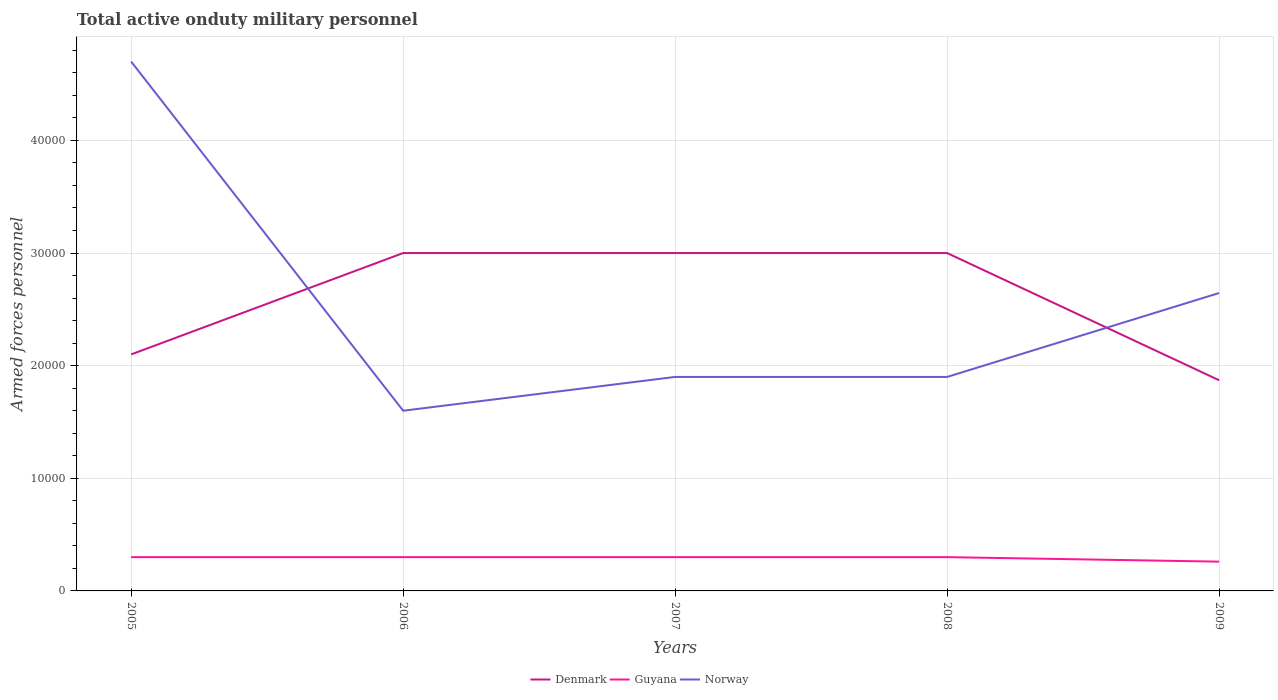Does the line corresponding to Denmark intersect with the line corresponding to Guyana?
Your response must be concise. No. Is the number of lines equal to the number of legend labels?
Keep it short and to the point. Yes. Across all years, what is the maximum number of armed forces personnel in Denmark?
Give a very brief answer. 1.87e+04. In which year was the number of armed forces personnel in Denmark maximum?
Your answer should be very brief. 2009. What is the total number of armed forces personnel in Guyana in the graph?
Your response must be concise. 400. What is the difference between the highest and the second highest number of armed forces personnel in Guyana?
Your answer should be compact. 400. What is the difference between the highest and the lowest number of armed forces personnel in Norway?
Offer a very short reply. 2. Is the number of armed forces personnel in Denmark strictly greater than the number of armed forces personnel in Guyana over the years?
Your answer should be very brief. No. How many years are there in the graph?
Your answer should be very brief. 5. What is the difference between two consecutive major ticks on the Y-axis?
Your answer should be compact. 10000. Are the values on the major ticks of Y-axis written in scientific E-notation?
Offer a terse response. No. Does the graph contain any zero values?
Ensure brevity in your answer.  No. Does the graph contain grids?
Offer a very short reply. Yes. Where does the legend appear in the graph?
Your answer should be compact. Bottom center. How are the legend labels stacked?
Your answer should be very brief. Horizontal. What is the title of the graph?
Offer a terse response. Total active onduty military personnel. What is the label or title of the X-axis?
Provide a short and direct response. Years. What is the label or title of the Y-axis?
Provide a succinct answer. Armed forces personnel. What is the Armed forces personnel in Denmark in 2005?
Give a very brief answer. 2.10e+04. What is the Armed forces personnel of Guyana in 2005?
Your response must be concise. 3000. What is the Armed forces personnel of Norway in 2005?
Your answer should be very brief. 4.70e+04. What is the Armed forces personnel of Denmark in 2006?
Provide a succinct answer. 3.00e+04. What is the Armed forces personnel of Guyana in 2006?
Your answer should be compact. 3000. What is the Armed forces personnel of Norway in 2006?
Keep it short and to the point. 1.60e+04. What is the Armed forces personnel of Denmark in 2007?
Provide a succinct answer. 3.00e+04. What is the Armed forces personnel in Guyana in 2007?
Offer a very short reply. 3000. What is the Armed forces personnel in Norway in 2007?
Provide a succinct answer. 1.90e+04. What is the Armed forces personnel in Denmark in 2008?
Provide a succinct answer. 3.00e+04. What is the Armed forces personnel of Guyana in 2008?
Your answer should be compact. 3000. What is the Armed forces personnel of Norway in 2008?
Keep it short and to the point. 1.90e+04. What is the Armed forces personnel of Denmark in 2009?
Your answer should be compact. 1.87e+04. What is the Armed forces personnel of Guyana in 2009?
Give a very brief answer. 2600. What is the Armed forces personnel of Norway in 2009?
Provide a short and direct response. 2.64e+04. Across all years, what is the maximum Armed forces personnel in Denmark?
Your answer should be very brief. 3.00e+04. Across all years, what is the maximum Armed forces personnel of Guyana?
Your answer should be compact. 3000. Across all years, what is the maximum Armed forces personnel in Norway?
Offer a very short reply. 4.70e+04. Across all years, what is the minimum Armed forces personnel of Denmark?
Your answer should be very brief. 1.87e+04. Across all years, what is the minimum Armed forces personnel of Guyana?
Provide a short and direct response. 2600. Across all years, what is the minimum Armed forces personnel of Norway?
Your answer should be compact. 1.60e+04. What is the total Armed forces personnel of Denmark in the graph?
Offer a very short reply. 1.30e+05. What is the total Armed forces personnel of Guyana in the graph?
Offer a very short reply. 1.46e+04. What is the total Armed forces personnel of Norway in the graph?
Ensure brevity in your answer.  1.27e+05. What is the difference between the Armed forces personnel in Denmark in 2005 and that in 2006?
Ensure brevity in your answer.  -9000. What is the difference between the Armed forces personnel in Norway in 2005 and that in 2006?
Your response must be concise. 3.10e+04. What is the difference between the Armed forces personnel in Denmark in 2005 and that in 2007?
Offer a very short reply. -9000. What is the difference between the Armed forces personnel of Norway in 2005 and that in 2007?
Keep it short and to the point. 2.80e+04. What is the difference between the Armed forces personnel in Denmark in 2005 and that in 2008?
Your answer should be compact. -9000. What is the difference between the Armed forces personnel of Guyana in 2005 and that in 2008?
Keep it short and to the point. 0. What is the difference between the Armed forces personnel of Norway in 2005 and that in 2008?
Your response must be concise. 2.80e+04. What is the difference between the Armed forces personnel of Denmark in 2005 and that in 2009?
Offer a terse response. 2293. What is the difference between the Armed forces personnel in Norway in 2005 and that in 2009?
Keep it short and to the point. 2.06e+04. What is the difference between the Armed forces personnel in Denmark in 2006 and that in 2007?
Your answer should be compact. 0. What is the difference between the Armed forces personnel in Norway in 2006 and that in 2007?
Give a very brief answer. -3000. What is the difference between the Armed forces personnel in Norway in 2006 and that in 2008?
Ensure brevity in your answer.  -3000. What is the difference between the Armed forces personnel of Denmark in 2006 and that in 2009?
Offer a terse response. 1.13e+04. What is the difference between the Armed forces personnel of Norway in 2006 and that in 2009?
Your answer should be compact. -1.04e+04. What is the difference between the Armed forces personnel in Denmark in 2007 and that in 2008?
Offer a very short reply. 0. What is the difference between the Armed forces personnel of Norway in 2007 and that in 2008?
Offer a very short reply. 0. What is the difference between the Armed forces personnel of Denmark in 2007 and that in 2009?
Provide a succinct answer. 1.13e+04. What is the difference between the Armed forces personnel of Norway in 2007 and that in 2009?
Your answer should be very brief. -7450. What is the difference between the Armed forces personnel of Denmark in 2008 and that in 2009?
Keep it short and to the point. 1.13e+04. What is the difference between the Armed forces personnel in Guyana in 2008 and that in 2009?
Your answer should be compact. 400. What is the difference between the Armed forces personnel in Norway in 2008 and that in 2009?
Ensure brevity in your answer.  -7450. What is the difference between the Armed forces personnel of Denmark in 2005 and the Armed forces personnel of Guyana in 2006?
Offer a very short reply. 1.80e+04. What is the difference between the Armed forces personnel in Guyana in 2005 and the Armed forces personnel in Norway in 2006?
Keep it short and to the point. -1.30e+04. What is the difference between the Armed forces personnel of Denmark in 2005 and the Armed forces personnel of Guyana in 2007?
Keep it short and to the point. 1.80e+04. What is the difference between the Armed forces personnel of Denmark in 2005 and the Armed forces personnel of Norway in 2007?
Keep it short and to the point. 2000. What is the difference between the Armed forces personnel of Guyana in 2005 and the Armed forces personnel of Norway in 2007?
Your response must be concise. -1.60e+04. What is the difference between the Armed forces personnel in Denmark in 2005 and the Armed forces personnel in Guyana in 2008?
Offer a very short reply. 1.80e+04. What is the difference between the Armed forces personnel in Denmark in 2005 and the Armed forces personnel in Norway in 2008?
Your answer should be compact. 2000. What is the difference between the Armed forces personnel of Guyana in 2005 and the Armed forces personnel of Norway in 2008?
Keep it short and to the point. -1.60e+04. What is the difference between the Armed forces personnel in Denmark in 2005 and the Armed forces personnel in Guyana in 2009?
Ensure brevity in your answer.  1.84e+04. What is the difference between the Armed forces personnel in Denmark in 2005 and the Armed forces personnel in Norway in 2009?
Your answer should be very brief. -5450. What is the difference between the Armed forces personnel in Guyana in 2005 and the Armed forces personnel in Norway in 2009?
Your response must be concise. -2.34e+04. What is the difference between the Armed forces personnel of Denmark in 2006 and the Armed forces personnel of Guyana in 2007?
Offer a terse response. 2.70e+04. What is the difference between the Armed forces personnel in Denmark in 2006 and the Armed forces personnel in Norway in 2007?
Your answer should be very brief. 1.10e+04. What is the difference between the Armed forces personnel of Guyana in 2006 and the Armed forces personnel of Norway in 2007?
Your response must be concise. -1.60e+04. What is the difference between the Armed forces personnel in Denmark in 2006 and the Armed forces personnel in Guyana in 2008?
Your response must be concise. 2.70e+04. What is the difference between the Armed forces personnel of Denmark in 2006 and the Armed forces personnel of Norway in 2008?
Give a very brief answer. 1.10e+04. What is the difference between the Armed forces personnel of Guyana in 2006 and the Armed forces personnel of Norway in 2008?
Ensure brevity in your answer.  -1.60e+04. What is the difference between the Armed forces personnel of Denmark in 2006 and the Armed forces personnel of Guyana in 2009?
Provide a succinct answer. 2.74e+04. What is the difference between the Armed forces personnel of Denmark in 2006 and the Armed forces personnel of Norway in 2009?
Your response must be concise. 3550. What is the difference between the Armed forces personnel in Guyana in 2006 and the Armed forces personnel in Norway in 2009?
Provide a short and direct response. -2.34e+04. What is the difference between the Armed forces personnel in Denmark in 2007 and the Armed forces personnel in Guyana in 2008?
Offer a very short reply. 2.70e+04. What is the difference between the Armed forces personnel of Denmark in 2007 and the Armed forces personnel of Norway in 2008?
Ensure brevity in your answer.  1.10e+04. What is the difference between the Armed forces personnel in Guyana in 2007 and the Armed forces personnel in Norway in 2008?
Offer a very short reply. -1.60e+04. What is the difference between the Armed forces personnel in Denmark in 2007 and the Armed forces personnel in Guyana in 2009?
Your answer should be compact. 2.74e+04. What is the difference between the Armed forces personnel of Denmark in 2007 and the Armed forces personnel of Norway in 2009?
Offer a terse response. 3550. What is the difference between the Armed forces personnel in Guyana in 2007 and the Armed forces personnel in Norway in 2009?
Your answer should be compact. -2.34e+04. What is the difference between the Armed forces personnel in Denmark in 2008 and the Armed forces personnel in Guyana in 2009?
Your response must be concise. 2.74e+04. What is the difference between the Armed forces personnel in Denmark in 2008 and the Armed forces personnel in Norway in 2009?
Your answer should be compact. 3550. What is the difference between the Armed forces personnel of Guyana in 2008 and the Armed forces personnel of Norway in 2009?
Ensure brevity in your answer.  -2.34e+04. What is the average Armed forces personnel of Denmark per year?
Offer a very short reply. 2.59e+04. What is the average Armed forces personnel in Guyana per year?
Your answer should be compact. 2920. What is the average Armed forces personnel of Norway per year?
Offer a very short reply. 2.55e+04. In the year 2005, what is the difference between the Armed forces personnel in Denmark and Armed forces personnel in Guyana?
Give a very brief answer. 1.80e+04. In the year 2005, what is the difference between the Armed forces personnel in Denmark and Armed forces personnel in Norway?
Give a very brief answer. -2.60e+04. In the year 2005, what is the difference between the Armed forces personnel of Guyana and Armed forces personnel of Norway?
Give a very brief answer. -4.40e+04. In the year 2006, what is the difference between the Armed forces personnel of Denmark and Armed forces personnel of Guyana?
Your response must be concise. 2.70e+04. In the year 2006, what is the difference between the Armed forces personnel of Denmark and Armed forces personnel of Norway?
Make the answer very short. 1.40e+04. In the year 2006, what is the difference between the Armed forces personnel in Guyana and Armed forces personnel in Norway?
Your answer should be compact. -1.30e+04. In the year 2007, what is the difference between the Armed forces personnel in Denmark and Armed forces personnel in Guyana?
Offer a terse response. 2.70e+04. In the year 2007, what is the difference between the Armed forces personnel of Denmark and Armed forces personnel of Norway?
Provide a succinct answer. 1.10e+04. In the year 2007, what is the difference between the Armed forces personnel in Guyana and Armed forces personnel in Norway?
Your response must be concise. -1.60e+04. In the year 2008, what is the difference between the Armed forces personnel in Denmark and Armed forces personnel in Guyana?
Your answer should be compact. 2.70e+04. In the year 2008, what is the difference between the Armed forces personnel in Denmark and Armed forces personnel in Norway?
Give a very brief answer. 1.10e+04. In the year 2008, what is the difference between the Armed forces personnel of Guyana and Armed forces personnel of Norway?
Your answer should be compact. -1.60e+04. In the year 2009, what is the difference between the Armed forces personnel in Denmark and Armed forces personnel in Guyana?
Your response must be concise. 1.61e+04. In the year 2009, what is the difference between the Armed forces personnel in Denmark and Armed forces personnel in Norway?
Make the answer very short. -7743. In the year 2009, what is the difference between the Armed forces personnel of Guyana and Armed forces personnel of Norway?
Offer a terse response. -2.38e+04. What is the ratio of the Armed forces personnel in Guyana in 2005 to that in 2006?
Offer a very short reply. 1. What is the ratio of the Armed forces personnel in Norway in 2005 to that in 2006?
Give a very brief answer. 2.94. What is the ratio of the Armed forces personnel in Norway in 2005 to that in 2007?
Your answer should be compact. 2.47. What is the ratio of the Armed forces personnel in Denmark in 2005 to that in 2008?
Ensure brevity in your answer.  0.7. What is the ratio of the Armed forces personnel in Guyana in 2005 to that in 2008?
Offer a very short reply. 1. What is the ratio of the Armed forces personnel of Norway in 2005 to that in 2008?
Make the answer very short. 2.47. What is the ratio of the Armed forces personnel in Denmark in 2005 to that in 2009?
Offer a terse response. 1.12. What is the ratio of the Armed forces personnel of Guyana in 2005 to that in 2009?
Provide a succinct answer. 1.15. What is the ratio of the Armed forces personnel of Norway in 2005 to that in 2009?
Your response must be concise. 1.78. What is the ratio of the Armed forces personnel of Denmark in 2006 to that in 2007?
Ensure brevity in your answer.  1. What is the ratio of the Armed forces personnel in Guyana in 2006 to that in 2007?
Make the answer very short. 1. What is the ratio of the Armed forces personnel in Norway in 2006 to that in 2007?
Keep it short and to the point. 0.84. What is the ratio of the Armed forces personnel in Denmark in 2006 to that in 2008?
Give a very brief answer. 1. What is the ratio of the Armed forces personnel of Norway in 2006 to that in 2008?
Ensure brevity in your answer.  0.84. What is the ratio of the Armed forces personnel in Denmark in 2006 to that in 2009?
Make the answer very short. 1.6. What is the ratio of the Armed forces personnel in Guyana in 2006 to that in 2009?
Ensure brevity in your answer.  1.15. What is the ratio of the Armed forces personnel in Norway in 2006 to that in 2009?
Ensure brevity in your answer.  0.6. What is the ratio of the Armed forces personnel in Denmark in 2007 to that in 2008?
Offer a terse response. 1. What is the ratio of the Armed forces personnel in Guyana in 2007 to that in 2008?
Give a very brief answer. 1. What is the ratio of the Armed forces personnel of Denmark in 2007 to that in 2009?
Your answer should be very brief. 1.6. What is the ratio of the Armed forces personnel of Guyana in 2007 to that in 2009?
Offer a very short reply. 1.15. What is the ratio of the Armed forces personnel in Norway in 2007 to that in 2009?
Provide a short and direct response. 0.72. What is the ratio of the Armed forces personnel of Denmark in 2008 to that in 2009?
Provide a succinct answer. 1.6. What is the ratio of the Armed forces personnel in Guyana in 2008 to that in 2009?
Keep it short and to the point. 1.15. What is the ratio of the Armed forces personnel of Norway in 2008 to that in 2009?
Offer a terse response. 0.72. What is the difference between the highest and the second highest Armed forces personnel of Denmark?
Offer a very short reply. 0. What is the difference between the highest and the second highest Armed forces personnel of Norway?
Provide a succinct answer. 2.06e+04. What is the difference between the highest and the lowest Armed forces personnel in Denmark?
Ensure brevity in your answer.  1.13e+04. What is the difference between the highest and the lowest Armed forces personnel of Norway?
Provide a short and direct response. 3.10e+04. 